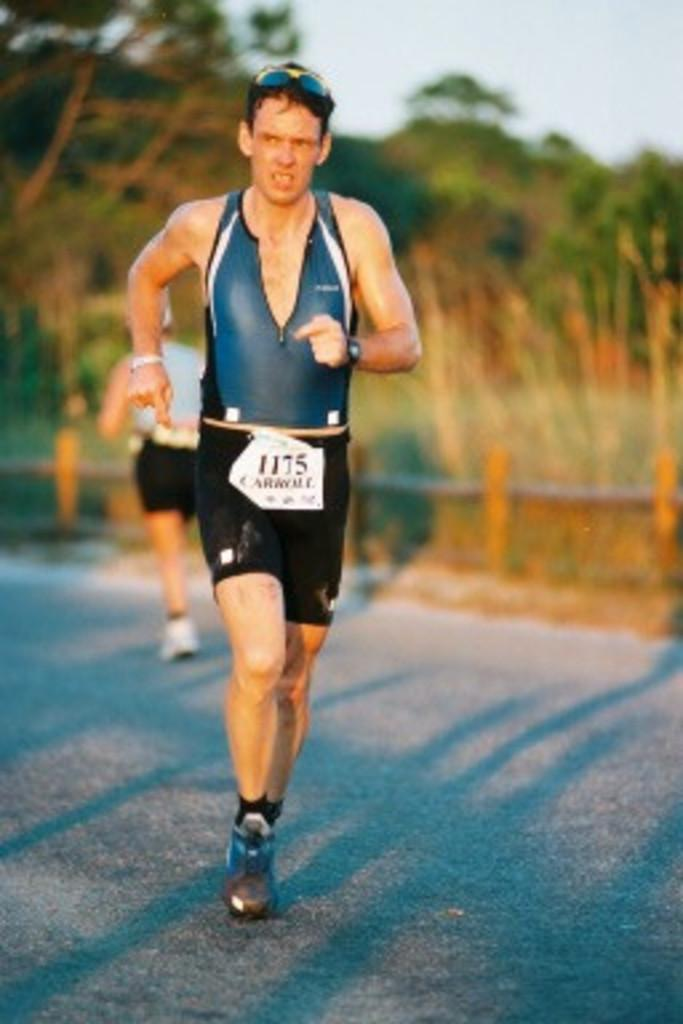What are the men in the image doing? The men in the image are running. Where are the men running? The men are running on a road. What can be seen in the background of the image? There are trees visible in the image. How would you describe the weather based on the image? The sky is cloudy in the image, suggesting a potentially overcast or cloudy day. What type of boot is the secretary wearing in the image? There is no secretary or boot present in the image; it features men running on a road with trees in the background and a cloudy sky. 